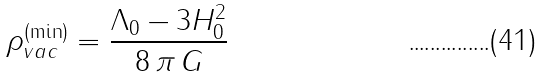<formula> <loc_0><loc_0><loc_500><loc_500>\rho _ { v a c } ^ { ( \min ) } = \frac { \Lambda _ { 0 } - 3 H _ { 0 } ^ { 2 } } { 8 \, \pi \, G }</formula> 